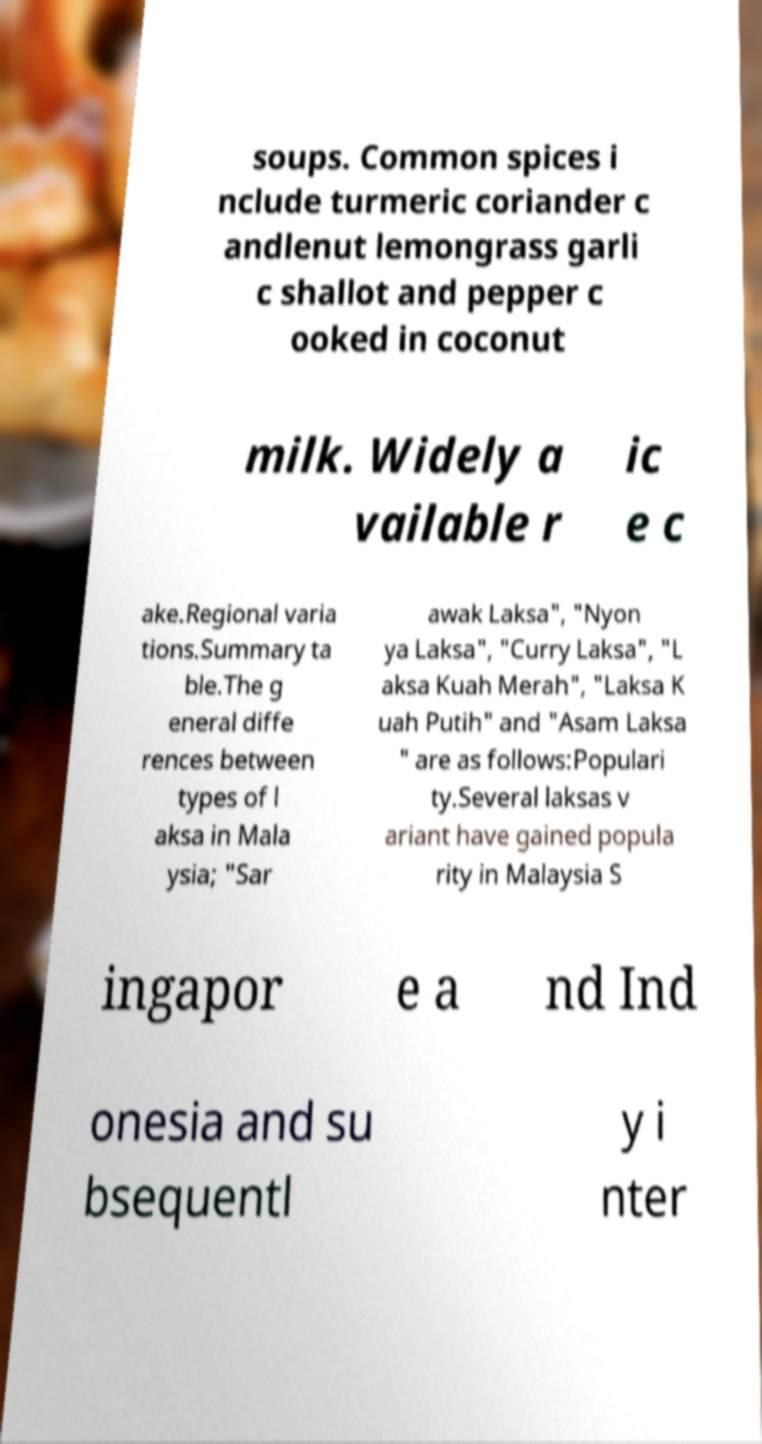Can you read and provide the text displayed in the image?This photo seems to have some interesting text. Can you extract and type it out for me? soups. Common spices i nclude turmeric coriander c andlenut lemongrass garli c shallot and pepper c ooked in coconut milk. Widely a vailable r ic e c ake.Regional varia tions.Summary ta ble.The g eneral diffe rences between types of l aksa in Mala ysia; "Sar awak Laksa", "Nyon ya Laksa", "Curry Laksa", "L aksa Kuah Merah", "Laksa K uah Putih" and "Asam Laksa " are as follows:Populari ty.Several laksas v ariant have gained popula rity in Malaysia S ingapor e a nd Ind onesia and su bsequentl y i nter 